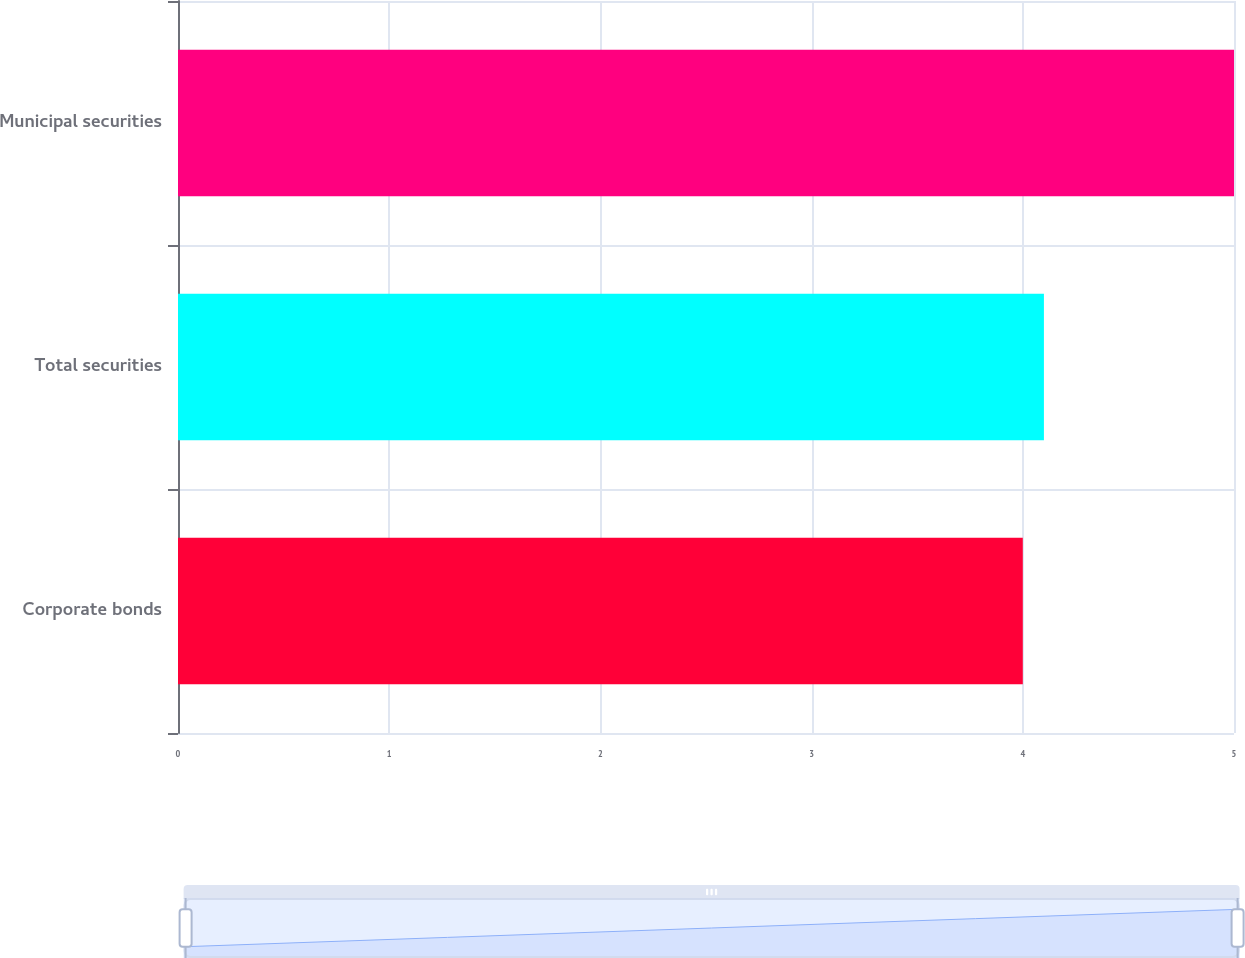Convert chart. <chart><loc_0><loc_0><loc_500><loc_500><bar_chart><fcel>Corporate bonds<fcel>Total securities<fcel>Municipal securities<nl><fcel>4<fcel>4.1<fcel>5<nl></chart> 